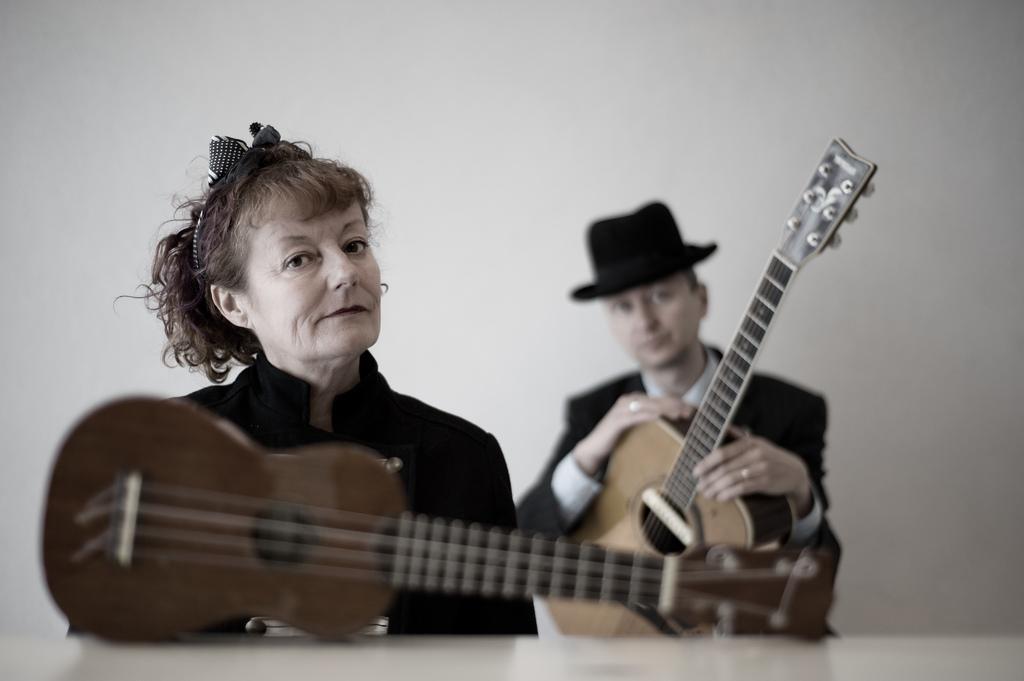Can you describe this image briefly? There are two people in the image. on the left there is a woman ,she is wearing a black jacket and her hair is small , in front of her there is a guitar. In the right there is a man he is holding a guitar and he is wearing a hat 